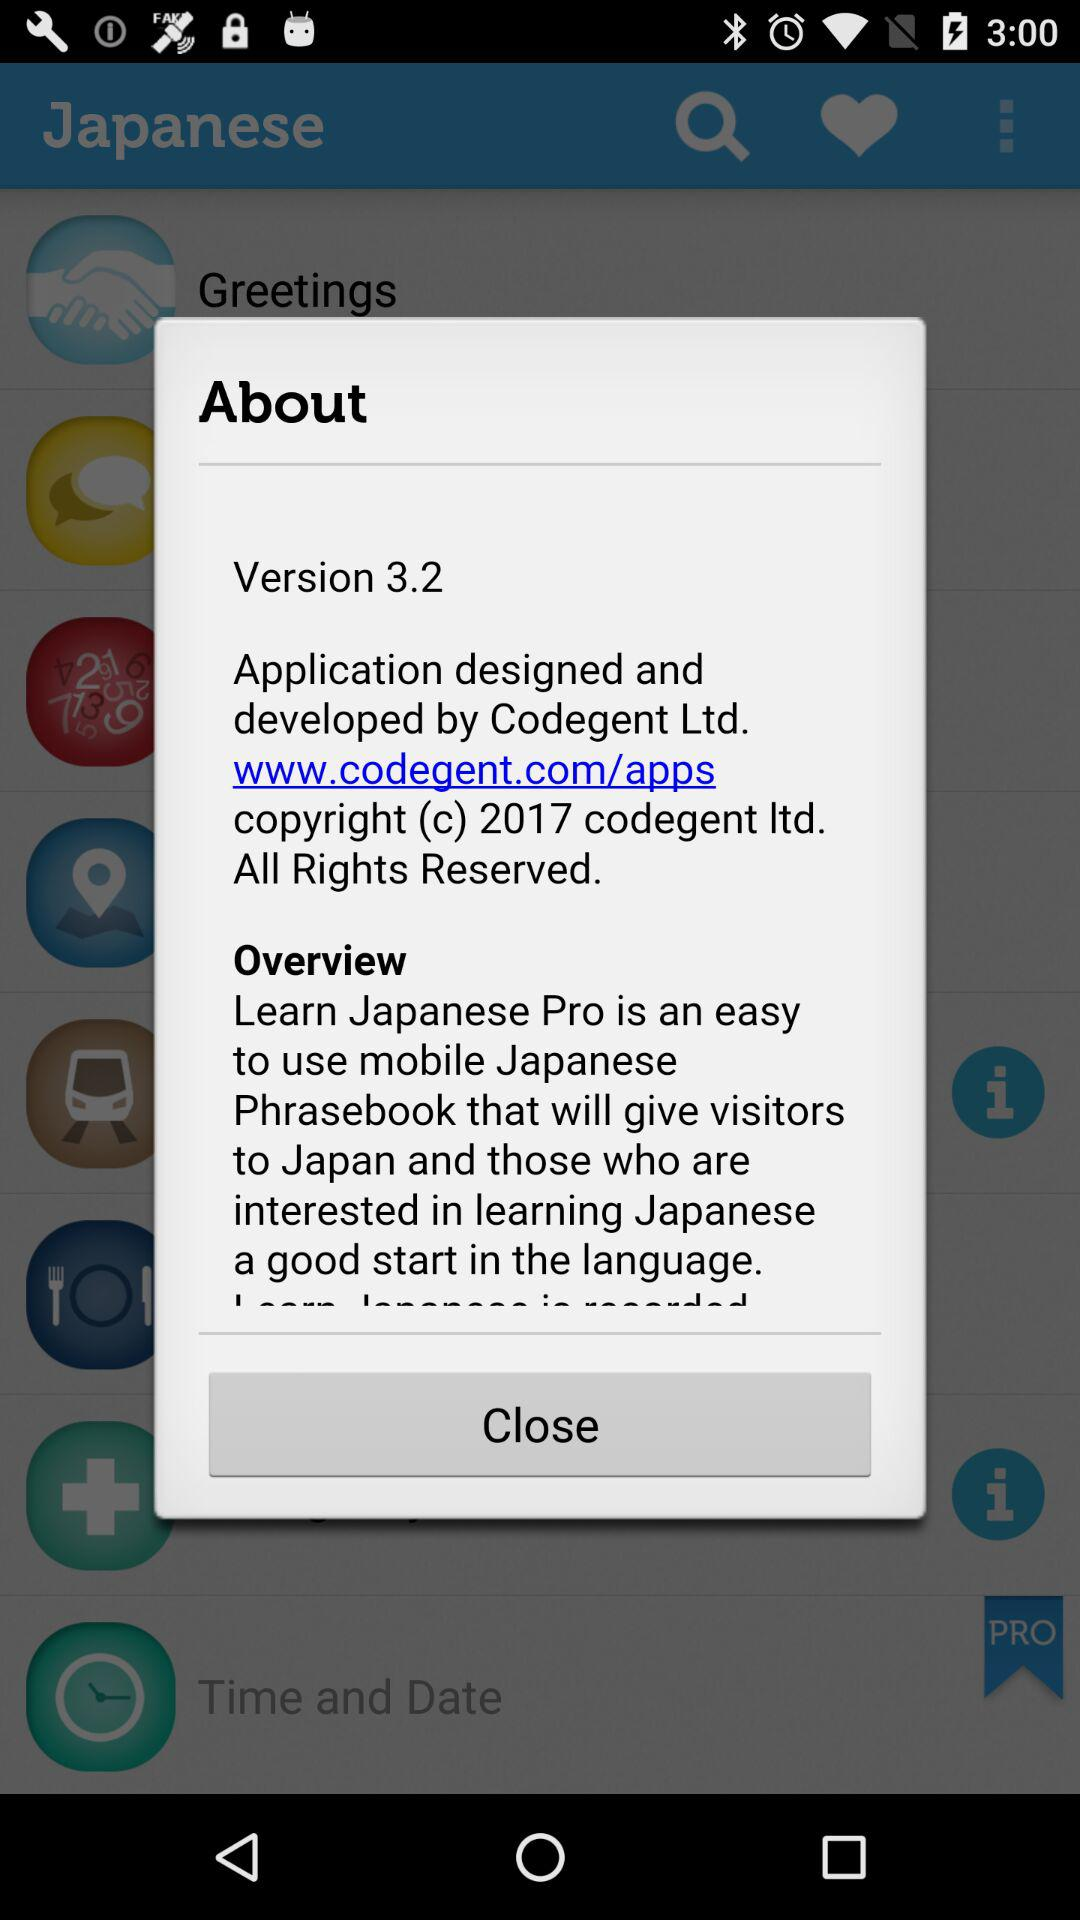What is the given email address?
When the provided information is insufficient, respond with <no answer>. <no answer> 